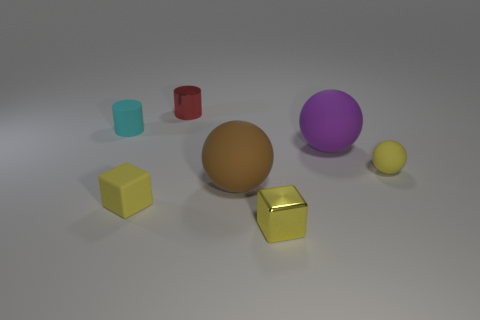Add 3 large green rubber cylinders. How many objects exist? 10 Subtract all cylinders. How many objects are left? 5 Subtract 0 red blocks. How many objects are left? 7 Subtract all tiny cylinders. Subtract all small cylinders. How many objects are left? 3 Add 3 yellow spheres. How many yellow spheres are left? 4 Add 7 tiny yellow blocks. How many tiny yellow blocks exist? 9 